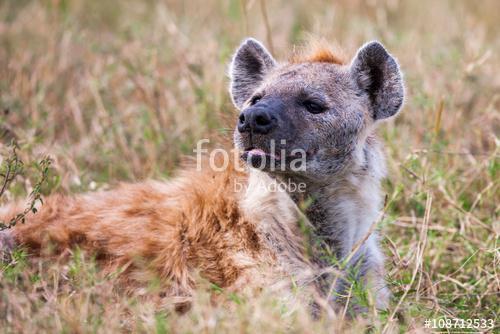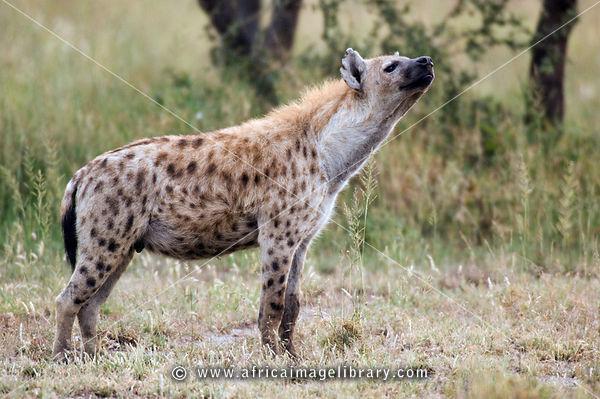The first image is the image on the left, the second image is the image on the right. For the images shown, is this caption "Each image contains multiple hyenas, and one image shows a fang-baring hyena next to one other hyena." true? Answer yes or no. No. The first image is the image on the left, the second image is the image on the right. For the images shown, is this caption "There are at least two hyenas in each image." true? Answer yes or no. No. 